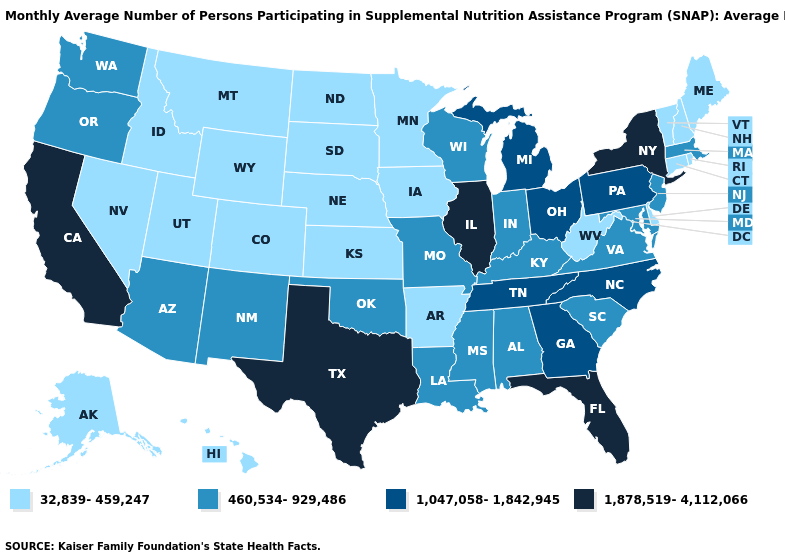Does Indiana have the highest value in the USA?
Be succinct. No. What is the value of Michigan?
Write a very short answer. 1,047,058-1,842,945. What is the value of Arkansas?
Be succinct. 32,839-459,247. What is the value of Kansas?
Be succinct. 32,839-459,247. Name the states that have a value in the range 1,047,058-1,842,945?
Short answer required. Georgia, Michigan, North Carolina, Ohio, Pennsylvania, Tennessee. Does Illinois have the highest value in the USA?
Answer briefly. Yes. Does the map have missing data?
Write a very short answer. No. Is the legend a continuous bar?
Answer briefly. No. Does South Dakota have the same value as Virginia?
Quick response, please. No. Among the states that border California , does Nevada have the lowest value?
Short answer required. Yes. What is the lowest value in the West?
Answer briefly. 32,839-459,247. What is the lowest value in the USA?
Write a very short answer. 32,839-459,247. What is the lowest value in the West?
Short answer required. 32,839-459,247. Among the states that border Kentucky , which have the highest value?
Be succinct. Illinois. 